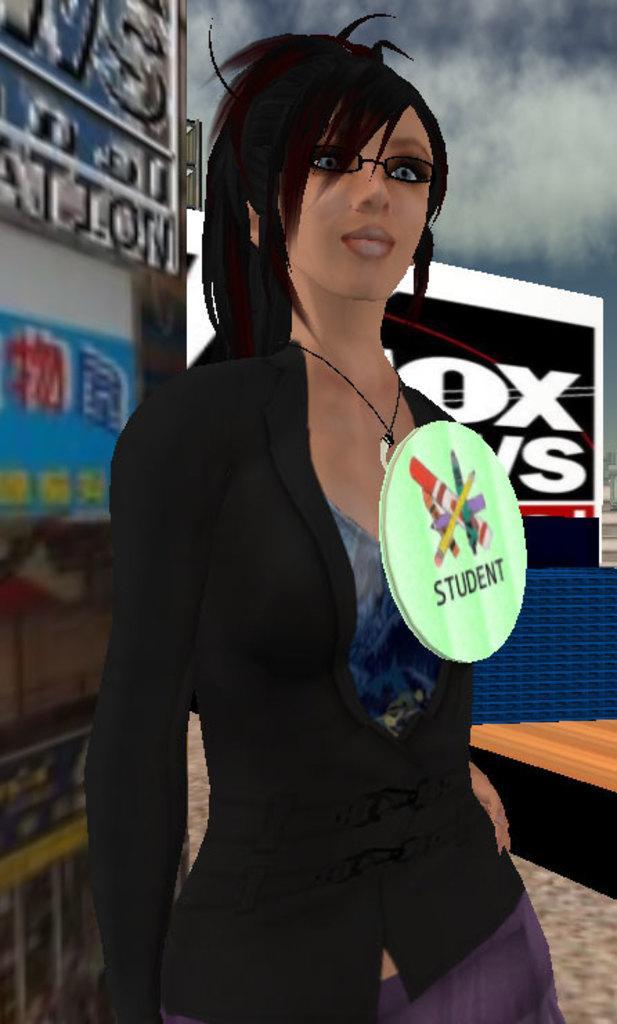How would you summarize this image in a sentence or two? This is an animated picture. In the center of the image we can see a lady is standing. In the background of the image we can see the boards, wall, table. At the bottom of the image we can see the floor. At the top of the image we can see the clouds are present in the sky. 